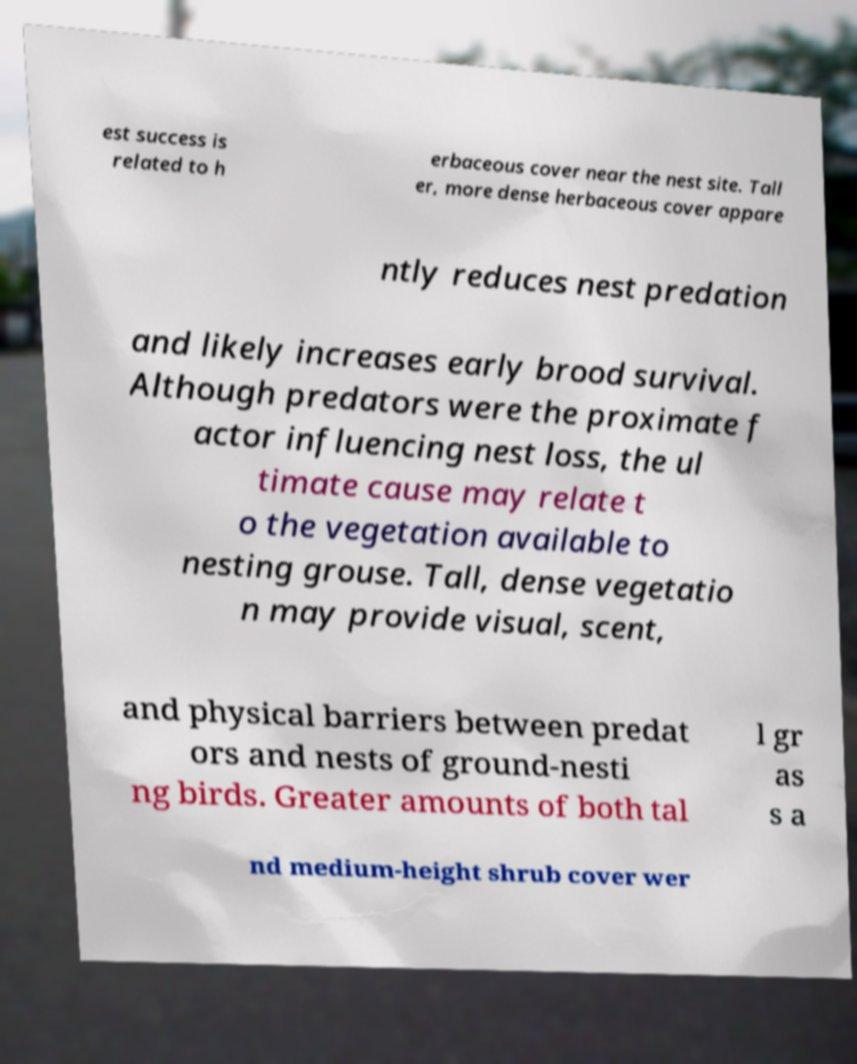Please read and relay the text visible in this image. What does it say? est success is related to h erbaceous cover near the nest site. Tall er, more dense herbaceous cover appare ntly reduces nest predation and likely increases early brood survival. Although predators were the proximate f actor influencing nest loss, the ul timate cause may relate t o the vegetation available to nesting grouse. Tall, dense vegetatio n may provide visual, scent, and physical barriers between predat ors and nests of ground-nesti ng birds. Greater amounts of both tal l gr as s a nd medium-height shrub cover wer 